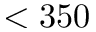Convert formula to latex. <formula><loc_0><loc_0><loc_500><loc_500>< 3 5 0</formula> 